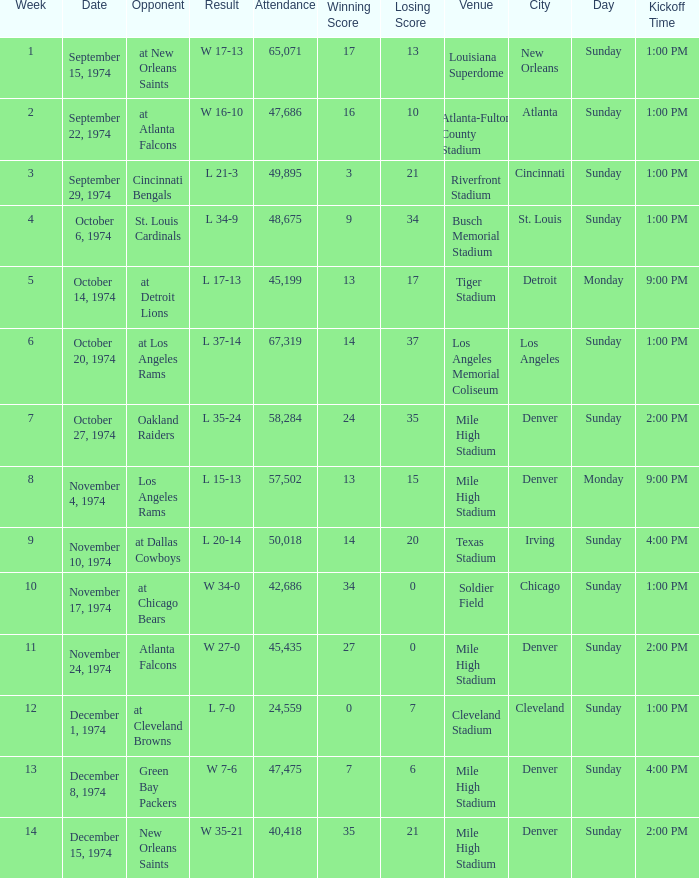What was the average attendance for games played at Atlanta Falcons? 47686.0. 